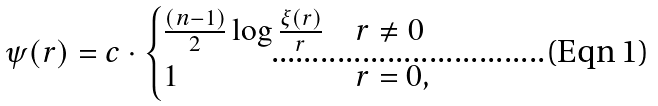<formula> <loc_0><loc_0><loc_500><loc_500>\psi ( r ) = c \cdot \begin{cases} \frac { ( n - 1 ) } { 2 } \log \frac { \xi ( r ) } { r } & r \neq 0 \\ 1 & r = 0 , \end{cases}</formula> 